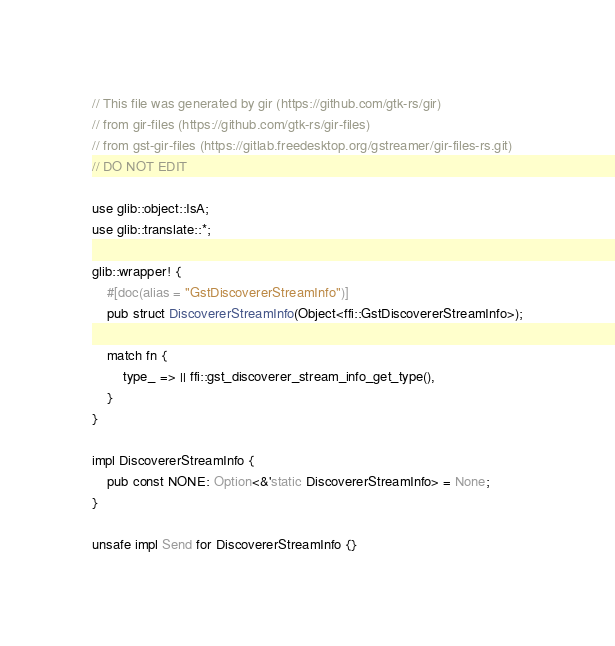Convert code to text. <code><loc_0><loc_0><loc_500><loc_500><_Rust_>// This file was generated by gir (https://github.com/gtk-rs/gir)
// from gir-files (https://github.com/gtk-rs/gir-files)
// from gst-gir-files (https://gitlab.freedesktop.org/gstreamer/gir-files-rs.git)
// DO NOT EDIT

use glib::object::IsA;
use glib::translate::*;

glib::wrapper! {
    #[doc(alias = "GstDiscovererStreamInfo")]
    pub struct DiscovererStreamInfo(Object<ffi::GstDiscovererStreamInfo>);

    match fn {
        type_ => || ffi::gst_discoverer_stream_info_get_type(),
    }
}

impl DiscovererStreamInfo {
    pub const NONE: Option<&'static DiscovererStreamInfo> = None;
}

unsafe impl Send for DiscovererStreamInfo {}</code> 